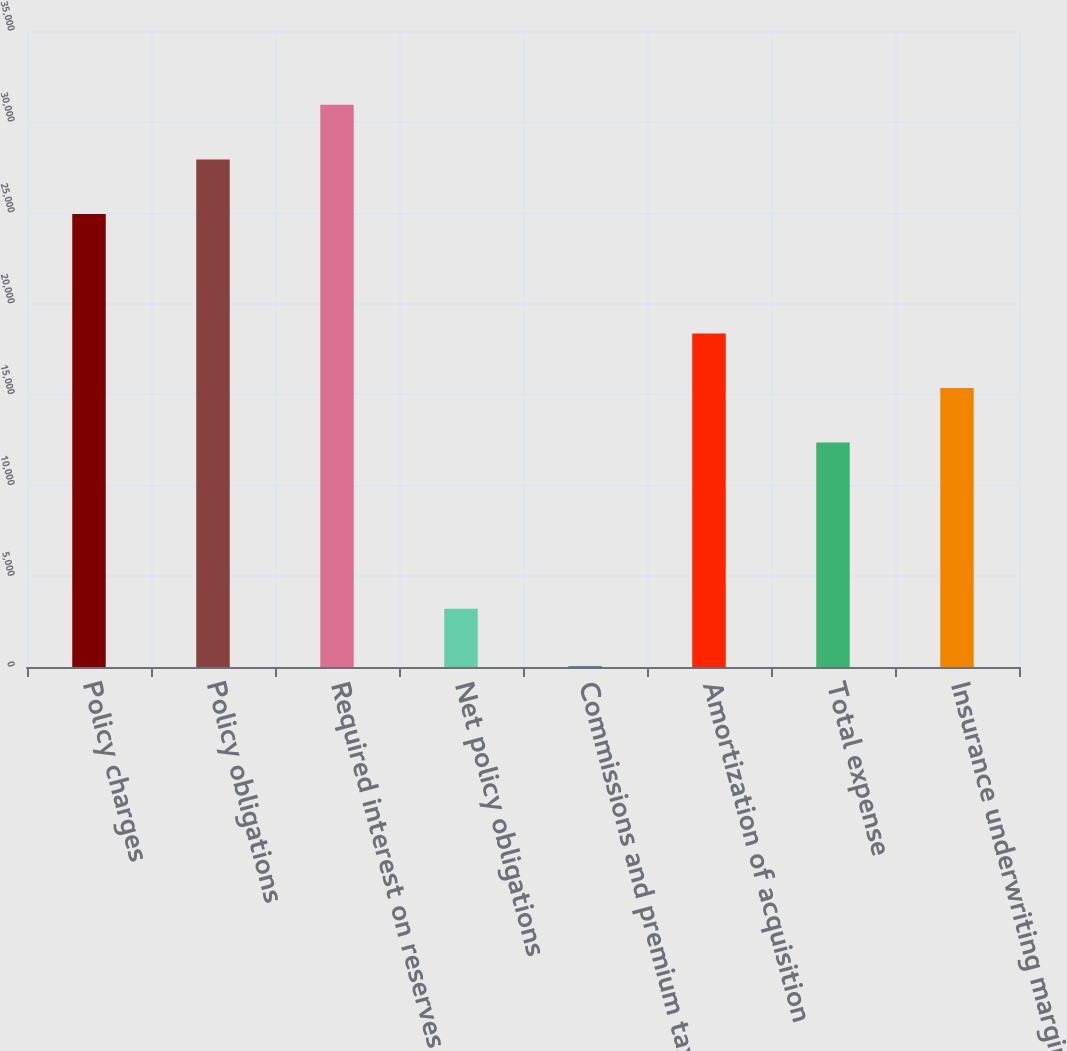<chart> <loc_0><loc_0><loc_500><loc_500><bar_chart><fcel>Policy charges<fcel>Policy obligations<fcel>Required interest on reserves<fcel>Net policy obligations<fcel>Commissions and premium taxes<fcel>Amortization of acquisition<fcel>Total expense<fcel>Insurance underwriting margin<nl><fcel>24929<fcel>27933.3<fcel>30937.6<fcel>3204<fcel>49<fcel>18357.6<fcel>12349<fcel>15353.3<nl></chart> 